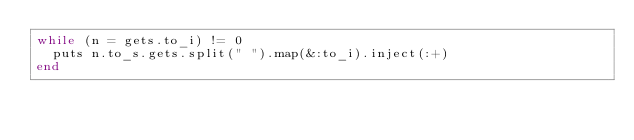Convert code to text. <code><loc_0><loc_0><loc_500><loc_500><_Ruby_>while (n = gets.to_i) != 0
  puts n.to_s.gets.split(" ").map(&:to_i).inject(:+)
end
</code> 